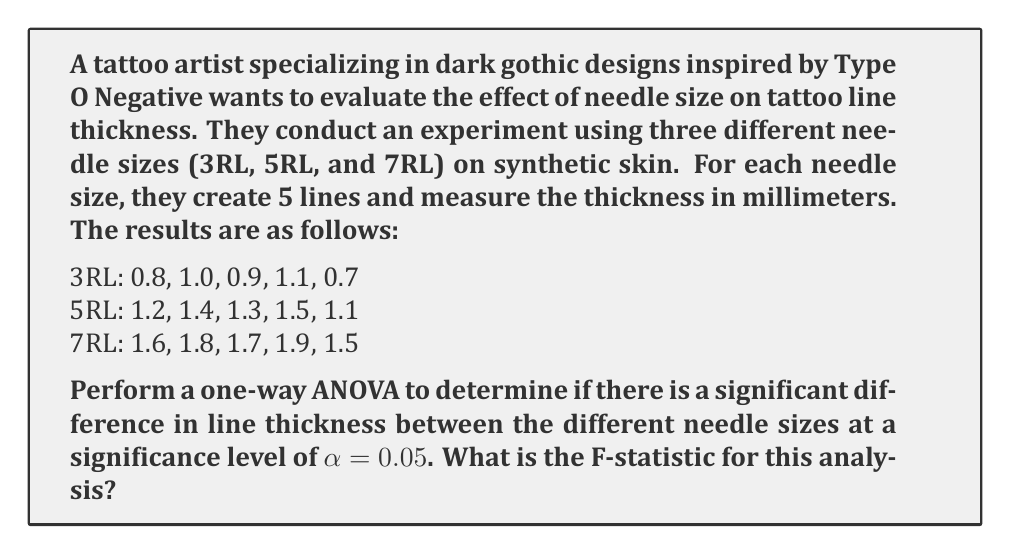What is the answer to this math problem? To perform a one-way ANOVA, we need to calculate the following:

1. Grand mean
2. Sum of Squares Total (SST)
3. Sum of Squares Between (SSB)
4. Sum of Squares Within (SSW)
5. Degrees of freedom
6. Mean Square Between (MSB)
7. Mean Square Within (MSW)
8. F-statistic

Step 1: Calculate the grand mean
$$\bar{X} = \frac{(0.8 + 1.0 + 0.9 + 1.1 + 0.7 + 1.2 + 1.4 + 1.3 + 1.5 + 1.1 + 1.6 + 1.8 + 1.7 + 1.9 + 1.5)}{15} = 1.3$$

Step 2: Calculate group means
3RL mean: $\bar{X}_1 = 0.9$
5RL mean: $\bar{X}_2 = 1.3$
7RL mean: $\bar{X}_3 = 1.7$

Step 3: Calculate SST
$$SST = \sum_{i=1}^{k}\sum_{j=1}^{n_i} (X_{ij} - \bar{X})^2 = 2.16$$

Step 4: Calculate SSB
$$SSB = \sum_{i=1}^{k} n_i(\bar{X}_i - \bar{X})^2 = 5 \cdot [(0.9 - 1.3)^2 + (1.3 - 1.3)^2 + (1.7 - 1.3)^2] = 2$$

Step 5: Calculate SSW
$$SSW = SST - SSB = 2.16 - 2 = 0.16$$

Step 6: Degrees of freedom
df(between) = k - 1 = 3 - 1 = 2
df(within) = N - k = 15 - 3 = 12
df(total) = N - 1 = 15 - 1 = 14

Step 7: Calculate MSB and MSW
$$MSB = \frac{SSB}{df(between)} = \frac{2}{2} = 1$$
$$MSW = \frac{SSW}{df(within)} = \frac{0.16}{12} = 0.0133$$

Step 8: Calculate F-statistic
$$F = \frac{MSB}{MSW} = \frac{1}{0.0133} = 75$$
Answer: The F-statistic for this one-way ANOVA is 75. 